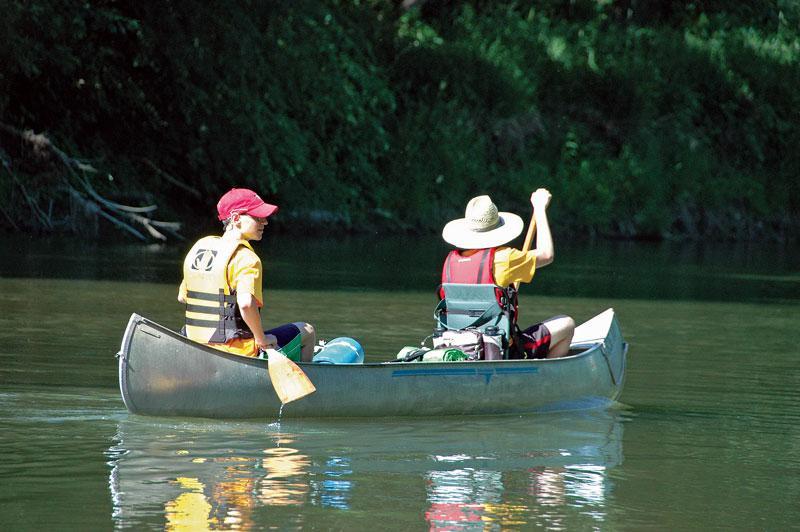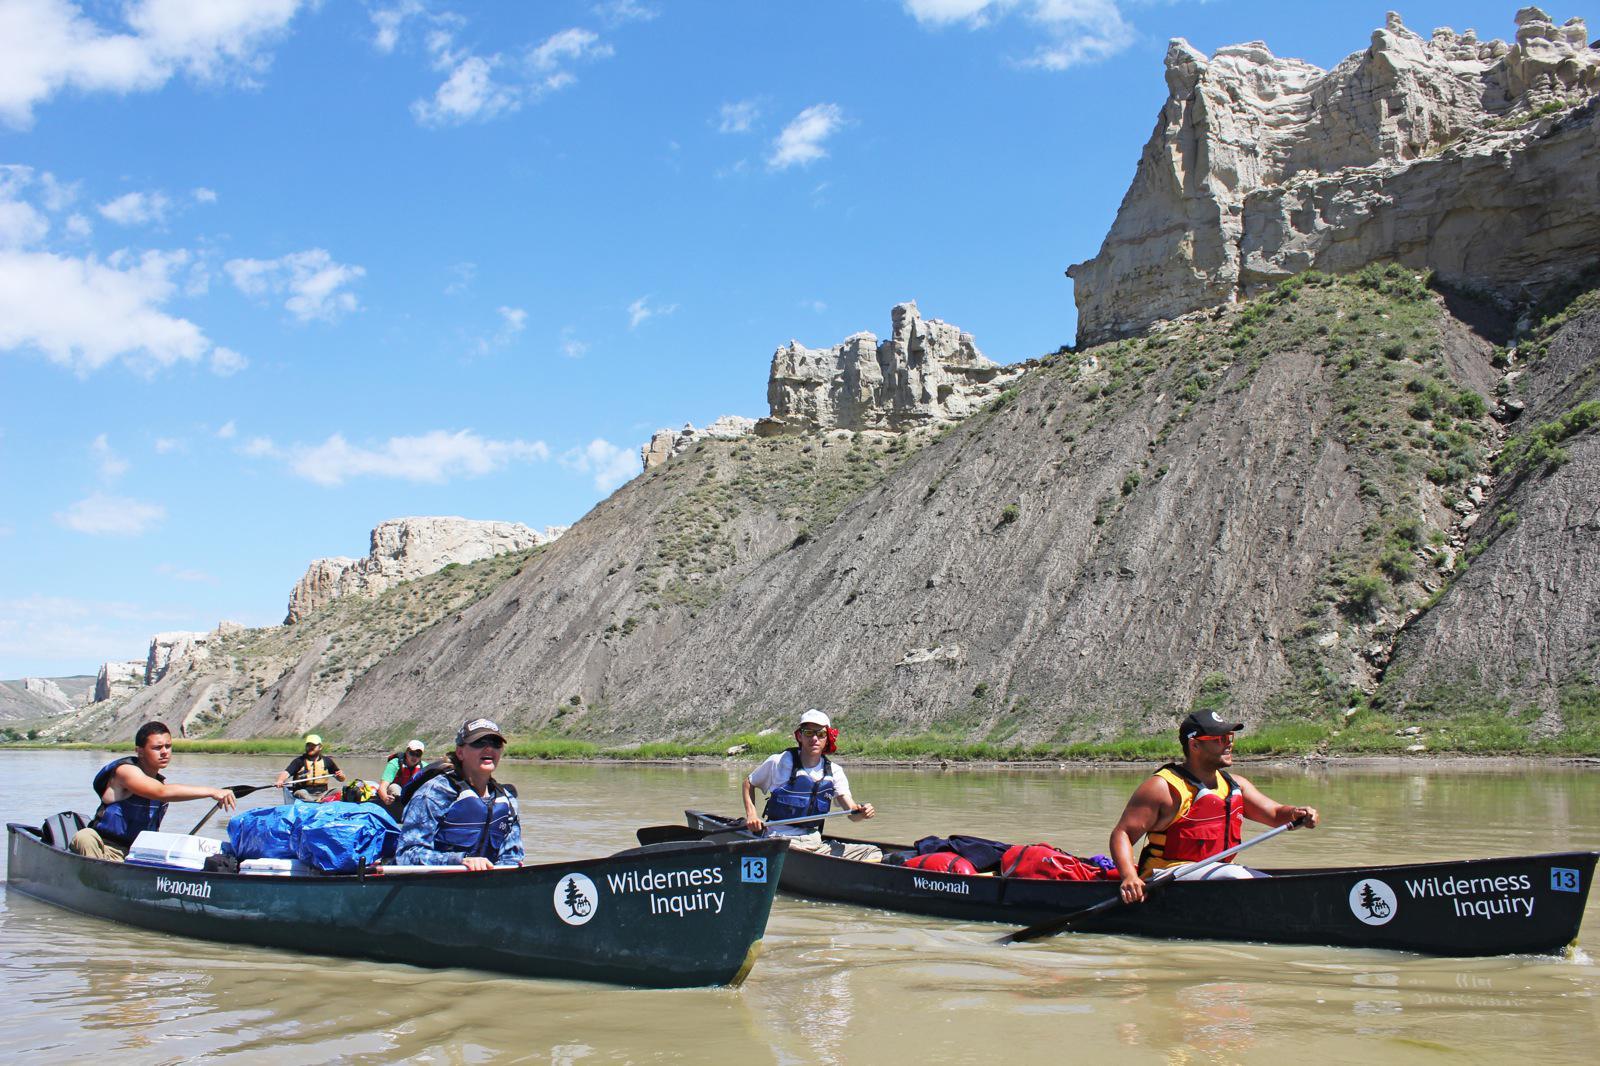The first image is the image on the left, the second image is the image on the right. Given the left and right images, does the statement "There are exactly three canoes." hold true? Answer yes or no. Yes. The first image is the image on the left, the second image is the image on the right. For the images displayed, is the sentence "The right image contains exactly two side-by-side canoes which are on the water and angled forward." factually correct? Answer yes or no. Yes. 